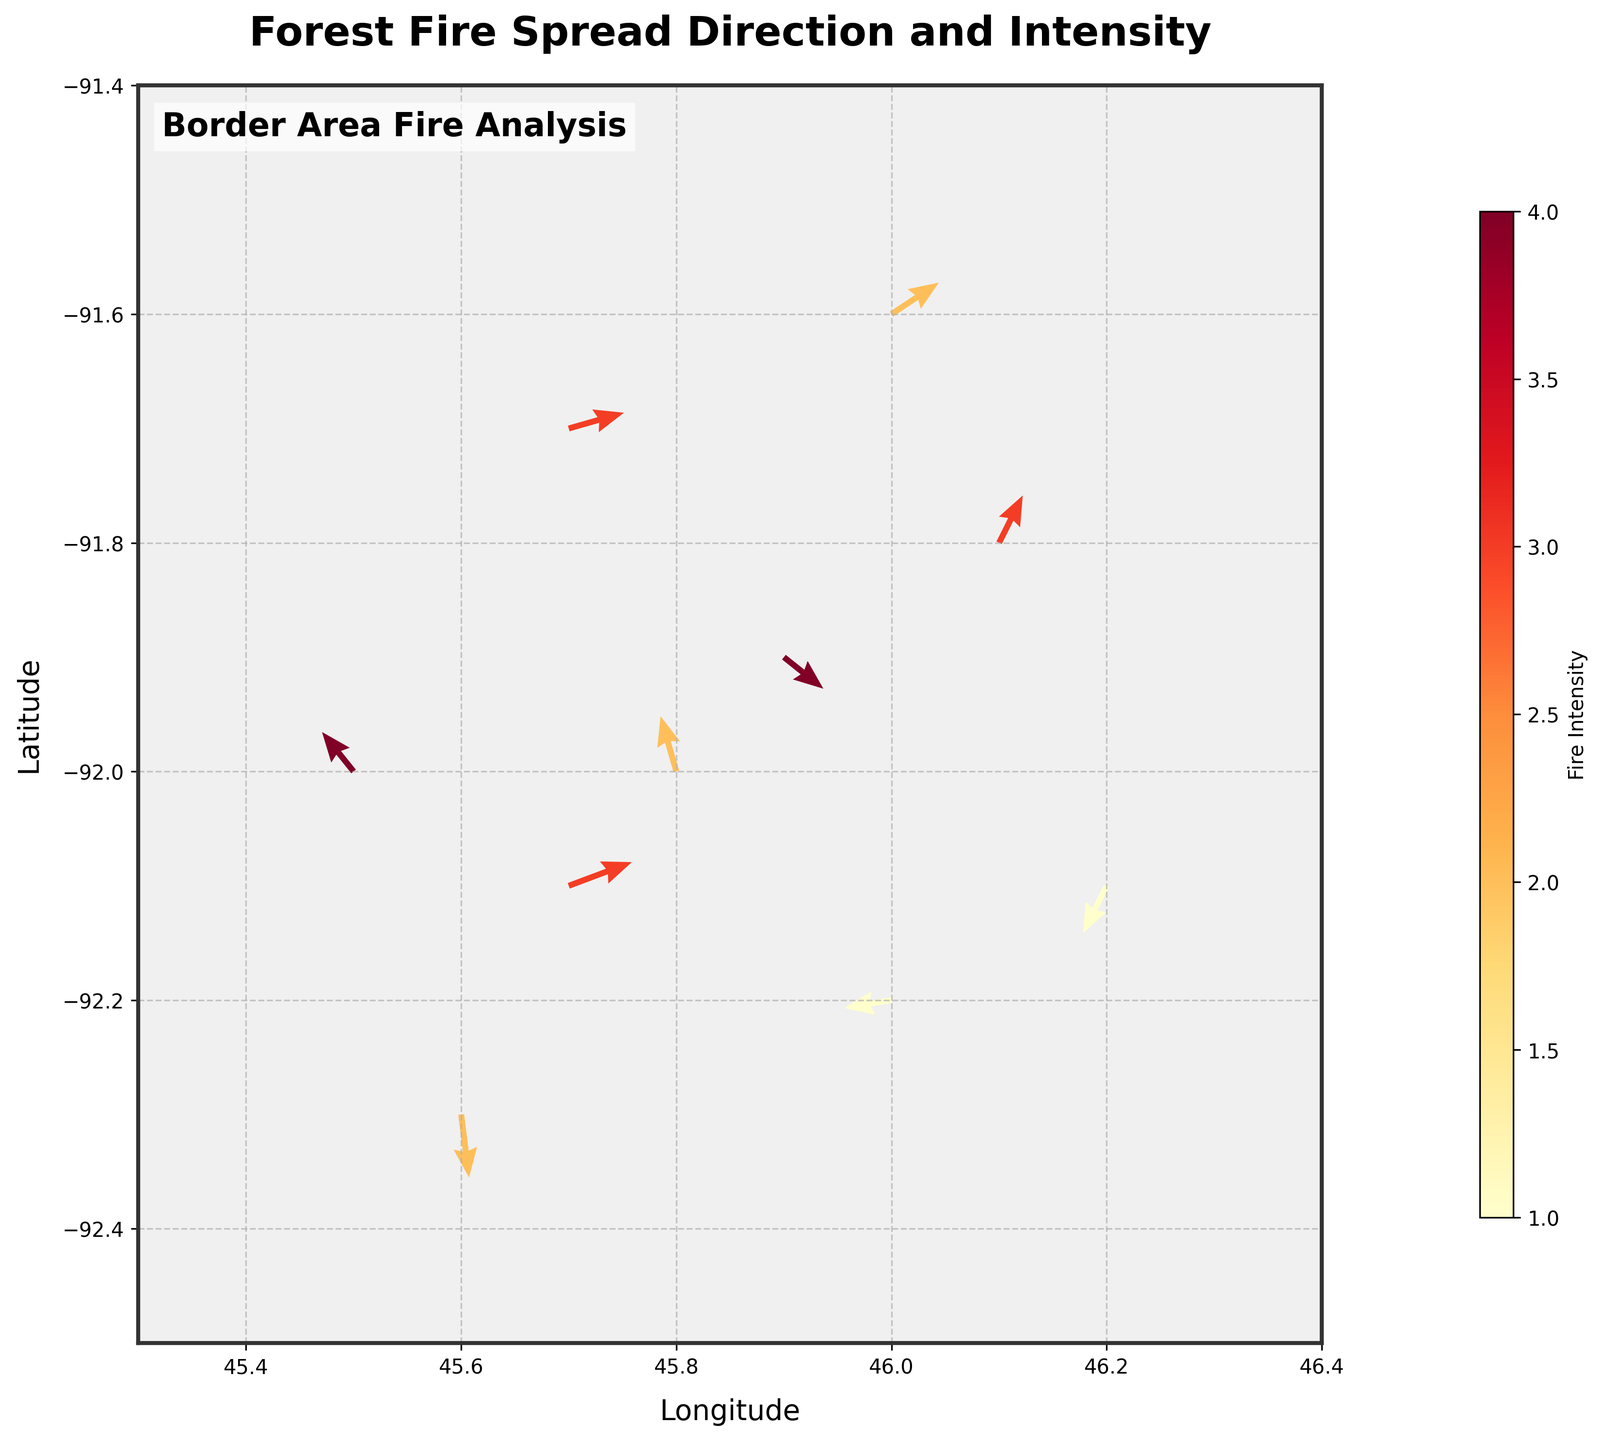What is the title of the plot? The title is located at the top of the figure and is emphasized in bold text. It indicates the subject of the plot.
Answer: Forest Fire Spread Direction and Intensity How many data points are displayed in the plot? Count the number of arrows shown in the plot, each representing a data point.
Answer: 10 Which axis represents the longitude? Both axes are labeled, with one labeled "Longitude" and the other "Latitude."
Answer: x-axis What color represents the highest fire intensity in the plot? The color scale to the right of the plot indicates that higher fire intensity is represented by a more intense red shade.
Answer: Red What is the fire intensity at the coordinates (45.9, -91.9)? Locate the arrow at (45.9, -91.9), and refer to the color scale to determine its intensity.
Answer: 4 In which direction is the fire spreading from coordinates (46.0, -91.6)? Check the direction of the arrow starting at (46.0, -91.6).
Answer: North-East Which data point shows the highest fire intensity and what are its coordinates? Identify the most intense red arrow and refer to its coordinates in the plot.
Answer: (45.9, -91.9) How many data points have their arrows pointing southwest? Count all arrows pointing towards the lower-left direction.
Answer: 2 What is the average intensity of the fires in the plot? Add up all the intensity values (3 + 2 + 4 + 1 + 3 + 2 + 4 + 3 + 1 + 2 = 25) and divide by the number of data points (10).
Answer: 2.5 Which data point shows a fire spreading south and what is its fire intensity? Identify the arrow pointing directly downward and check the intensity using the color scale.
Answer: (45.6, -92.3), 2 